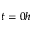Convert formula to latex. <formula><loc_0><loc_0><loc_500><loc_500>t = 0 h</formula> 